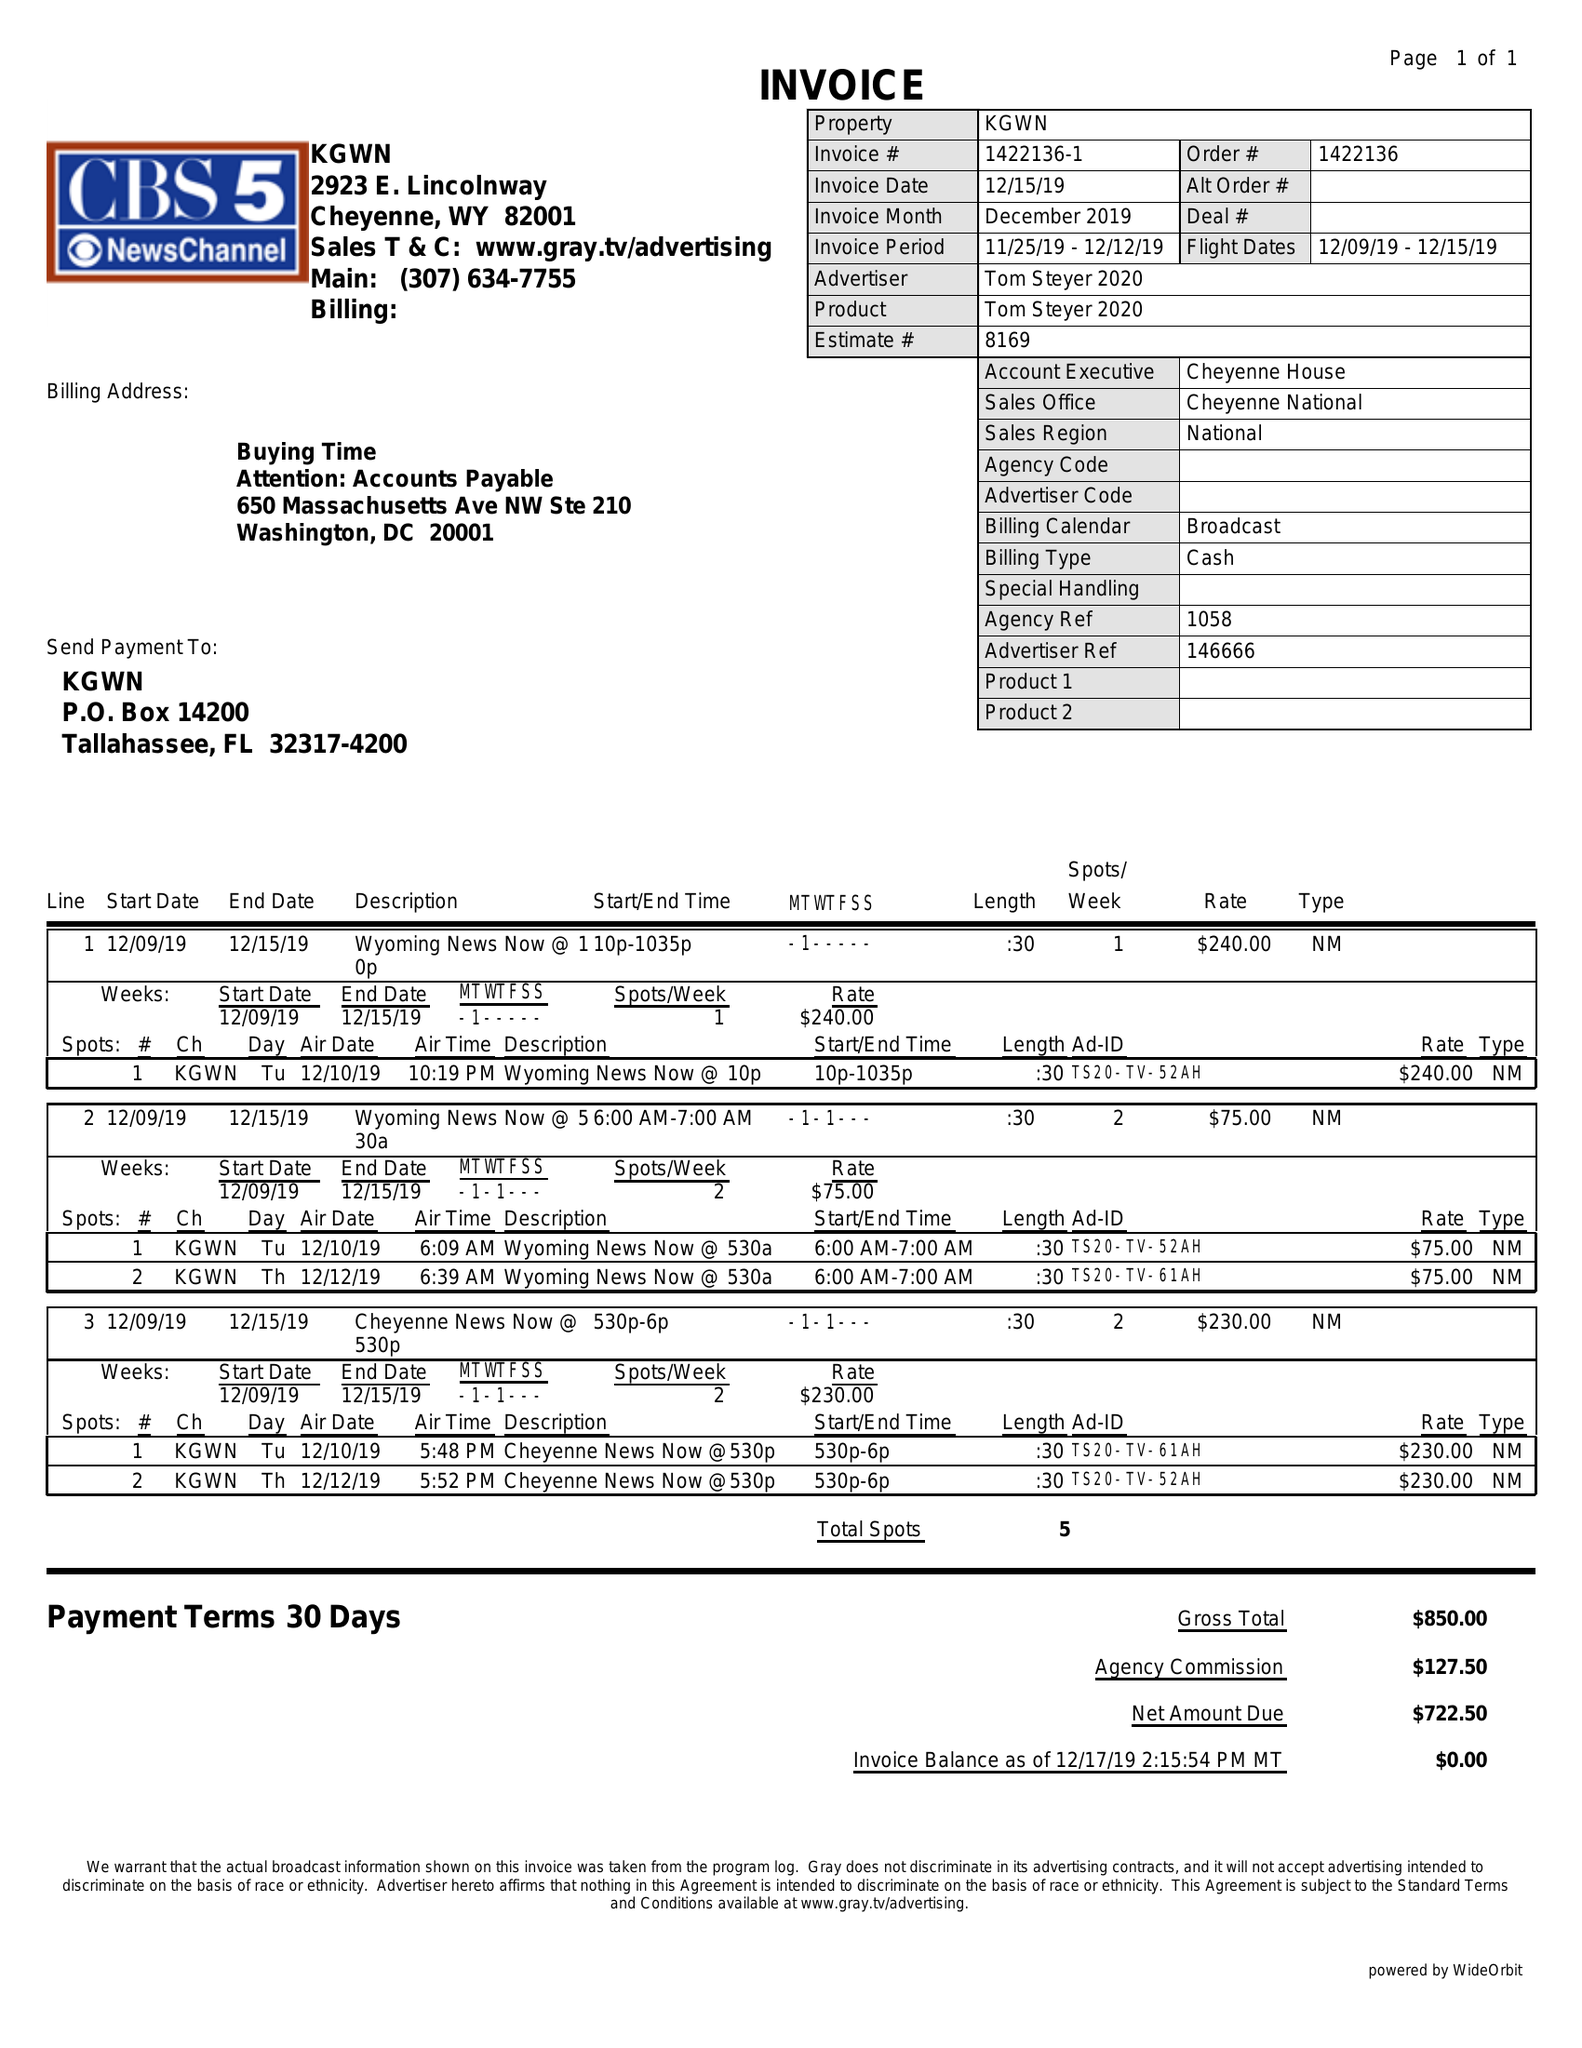What is the value for the flight_from?
Answer the question using a single word or phrase. 12/09/19 